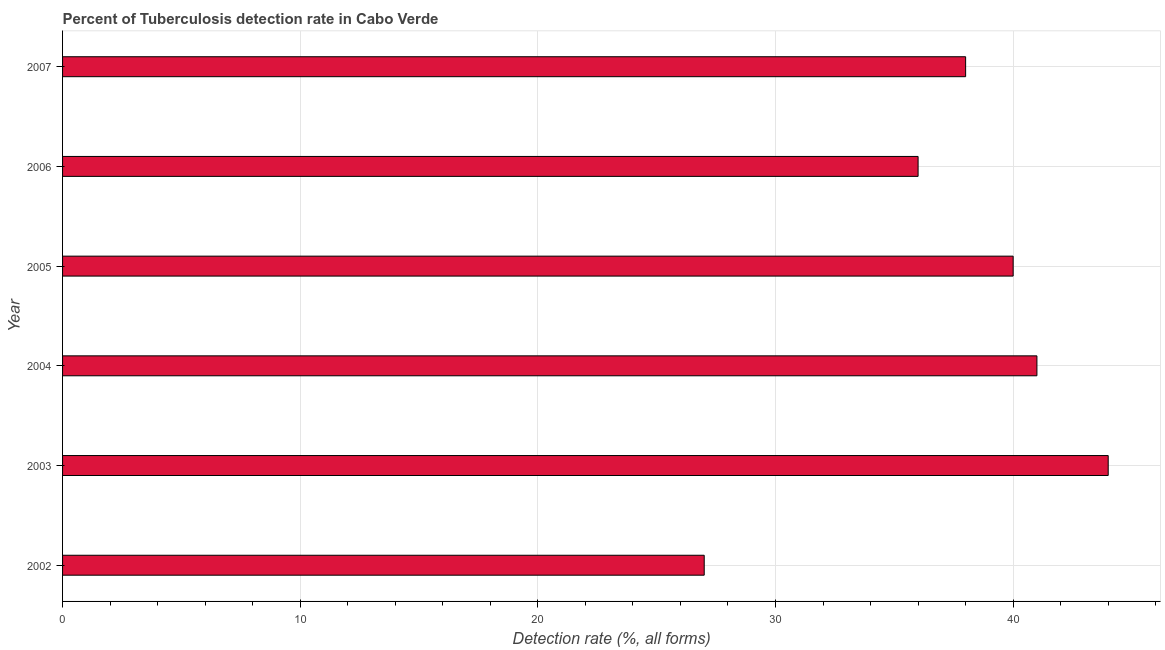What is the title of the graph?
Make the answer very short. Percent of Tuberculosis detection rate in Cabo Verde. What is the label or title of the X-axis?
Your response must be concise. Detection rate (%, all forms). What is the detection rate of tuberculosis in 2007?
Ensure brevity in your answer.  38. Across all years, what is the maximum detection rate of tuberculosis?
Offer a terse response. 44. Across all years, what is the minimum detection rate of tuberculosis?
Offer a very short reply. 27. In which year was the detection rate of tuberculosis minimum?
Offer a very short reply. 2002. What is the sum of the detection rate of tuberculosis?
Your answer should be compact. 226. What is the difference between the detection rate of tuberculosis in 2002 and 2005?
Give a very brief answer. -13. What is the average detection rate of tuberculosis per year?
Your response must be concise. 37. What is the median detection rate of tuberculosis?
Ensure brevity in your answer.  39. In how many years, is the detection rate of tuberculosis greater than 14 %?
Provide a short and direct response. 6. Do a majority of the years between 2003 and 2005 (inclusive) have detection rate of tuberculosis greater than 18 %?
Your answer should be compact. Yes. What is the ratio of the detection rate of tuberculosis in 2002 to that in 2004?
Give a very brief answer. 0.66. Is the sum of the detection rate of tuberculosis in 2002 and 2003 greater than the maximum detection rate of tuberculosis across all years?
Your answer should be very brief. Yes. How many bars are there?
Offer a very short reply. 6. Are all the bars in the graph horizontal?
Keep it short and to the point. Yes. How many years are there in the graph?
Give a very brief answer. 6. What is the Detection rate (%, all forms) of 2002?
Provide a short and direct response. 27. What is the Detection rate (%, all forms) in 2005?
Your response must be concise. 40. What is the difference between the Detection rate (%, all forms) in 2002 and 2003?
Your response must be concise. -17. What is the difference between the Detection rate (%, all forms) in 2002 and 2005?
Provide a succinct answer. -13. What is the difference between the Detection rate (%, all forms) in 2003 and 2004?
Provide a succinct answer. 3. What is the difference between the Detection rate (%, all forms) in 2003 and 2006?
Make the answer very short. 8. What is the difference between the Detection rate (%, all forms) in 2003 and 2007?
Offer a very short reply. 6. What is the difference between the Detection rate (%, all forms) in 2004 and 2007?
Your answer should be compact. 3. What is the difference between the Detection rate (%, all forms) in 2005 and 2006?
Provide a short and direct response. 4. What is the difference between the Detection rate (%, all forms) in 2005 and 2007?
Provide a succinct answer. 2. What is the difference between the Detection rate (%, all forms) in 2006 and 2007?
Provide a succinct answer. -2. What is the ratio of the Detection rate (%, all forms) in 2002 to that in 2003?
Your answer should be very brief. 0.61. What is the ratio of the Detection rate (%, all forms) in 2002 to that in 2004?
Give a very brief answer. 0.66. What is the ratio of the Detection rate (%, all forms) in 2002 to that in 2005?
Keep it short and to the point. 0.68. What is the ratio of the Detection rate (%, all forms) in 2002 to that in 2006?
Give a very brief answer. 0.75. What is the ratio of the Detection rate (%, all forms) in 2002 to that in 2007?
Make the answer very short. 0.71. What is the ratio of the Detection rate (%, all forms) in 2003 to that in 2004?
Your answer should be compact. 1.07. What is the ratio of the Detection rate (%, all forms) in 2003 to that in 2006?
Offer a terse response. 1.22. What is the ratio of the Detection rate (%, all forms) in 2003 to that in 2007?
Your answer should be very brief. 1.16. What is the ratio of the Detection rate (%, all forms) in 2004 to that in 2005?
Provide a short and direct response. 1.02. What is the ratio of the Detection rate (%, all forms) in 2004 to that in 2006?
Your answer should be very brief. 1.14. What is the ratio of the Detection rate (%, all forms) in 2004 to that in 2007?
Provide a short and direct response. 1.08. What is the ratio of the Detection rate (%, all forms) in 2005 to that in 2006?
Offer a very short reply. 1.11. What is the ratio of the Detection rate (%, all forms) in 2005 to that in 2007?
Offer a terse response. 1.05. What is the ratio of the Detection rate (%, all forms) in 2006 to that in 2007?
Keep it short and to the point. 0.95. 